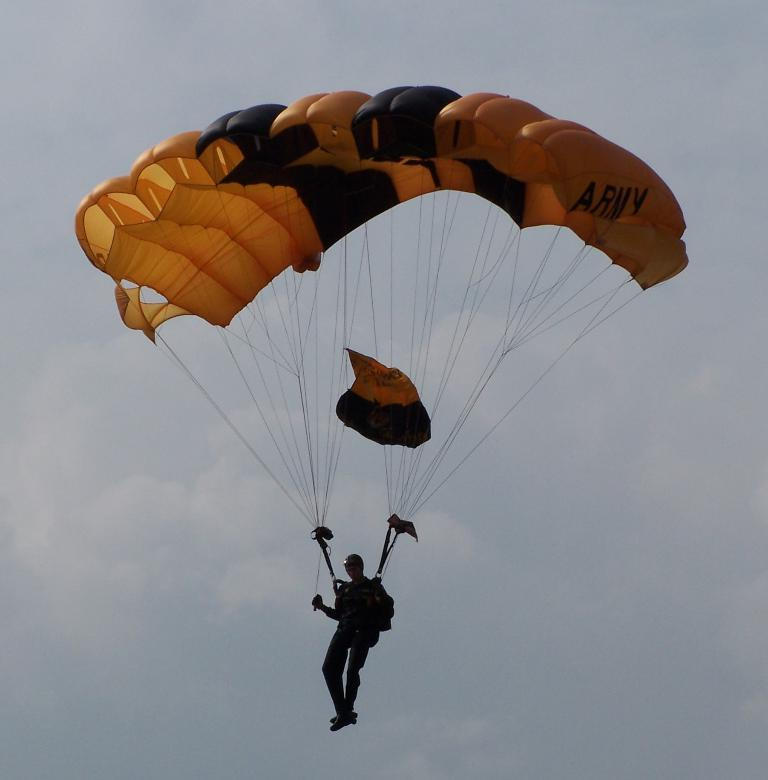What is the main subject of the image? There is a person in the image. What is the person doing in the image? The person is flying in the air. How is the person flying in the air? The person is using a parachute. What safety gear is the person wearing? The person is wearing a helmet. How would you describe the weather in the image? The sky is cloudy. What type of salt can be seen on the chair in the image? There is no salt or chair present in the image. How much milk is being poured by the person in the image? There is no milk or pouring action present in the image. 